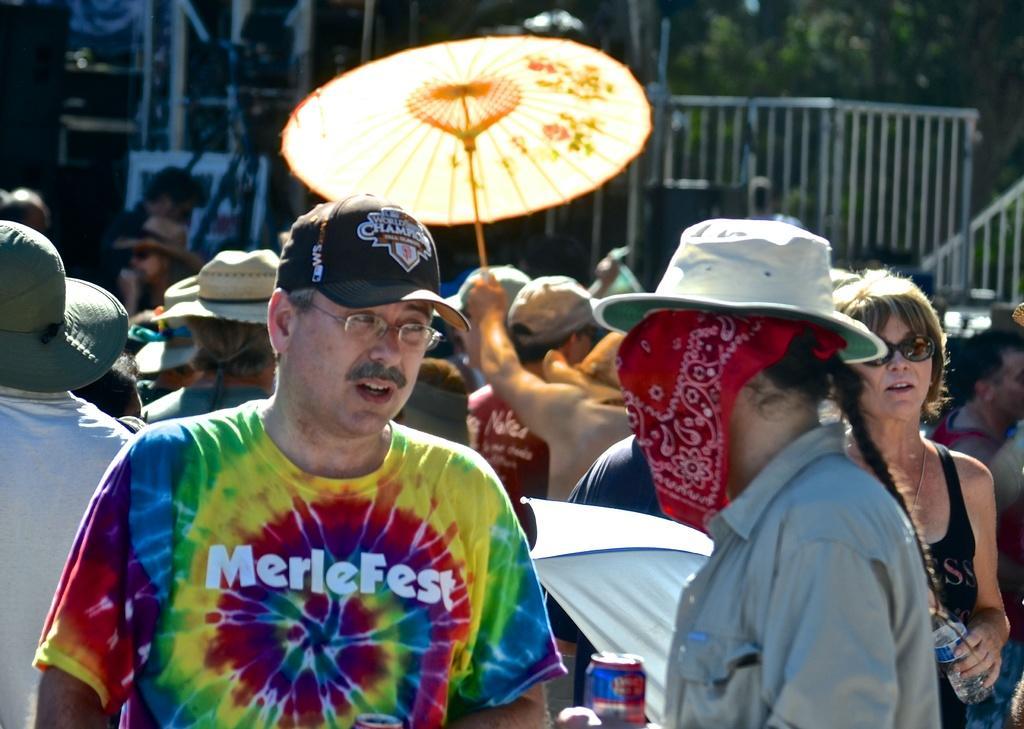Can you describe this image briefly? In this image I can see group of people standing. In front the person is wearing multi color shirt and the other person is holding an umbrella. In the background I can see the railing and few trees in green color. 